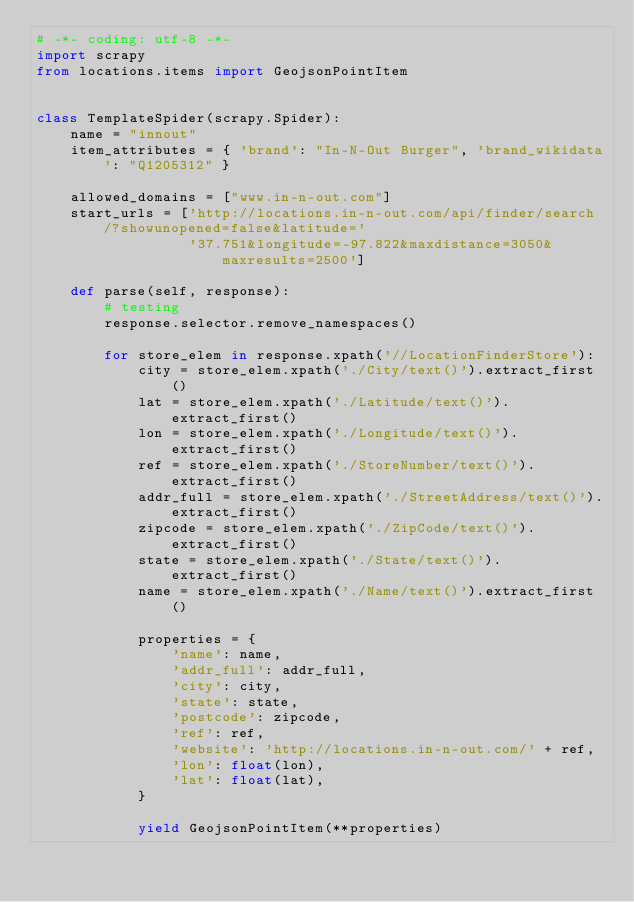Convert code to text. <code><loc_0><loc_0><loc_500><loc_500><_Python_># -*- coding: utf-8 -*-
import scrapy
from locations.items import GeojsonPointItem


class TemplateSpider(scrapy.Spider):
    name = "innout"
    item_attributes = { 'brand': "In-N-Out Burger", 'brand_wikidata': "Q1205312" }

    allowed_domains = ["www.in-n-out.com"]
    start_urls = ['http://locations.in-n-out.com/api/finder/search/?showunopened=false&latitude='
                  '37.751&longitude=-97.822&maxdistance=3050&maxresults=2500']

    def parse(self, response):
        # testing
        response.selector.remove_namespaces()

        for store_elem in response.xpath('//LocationFinderStore'):
            city = store_elem.xpath('./City/text()').extract_first()
            lat = store_elem.xpath('./Latitude/text()').extract_first()
            lon = store_elem.xpath('./Longitude/text()').extract_first()
            ref = store_elem.xpath('./StoreNumber/text()').extract_first()
            addr_full = store_elem.xpath('./StreetAddress/text()').extract_first()
            zipcode = store_elem.xpath('./ZipCode/text()').extract_first()
            state = store_elem.xpath('./State/text()').extract_first()
            name = store_elem.xpath('./Name/text()').extract_first()

            properties = {
                'name': name,
                'addr_full': addr_full,
                'city': city,
                'state': state,
                'postcode': zipcode,
                'ref': ref,
                'website': 'http://locations.in-n-out.com/' + ref,
                'lon': float(lon),
                'lat': float(lat),
            }

            yield GeojsonPointItem(**properties)
</code> 